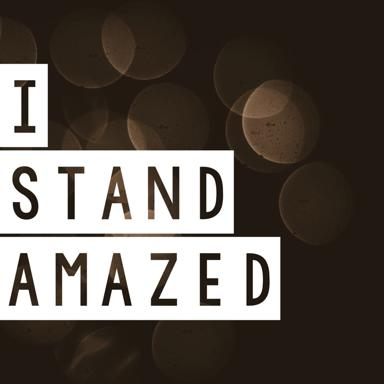What are the texts on the image? The text visible on the image includes two phrases: 'I Stand Amazed' and potentially a typographical variation or visual similarity in '1 Stand Amazed.' Each phrase is displayed in a clear, sans-serif font against a background with a softly blurred, bokeh effect, which could symbolize the confusion or overwhelming sensation often associated with being amazed. 